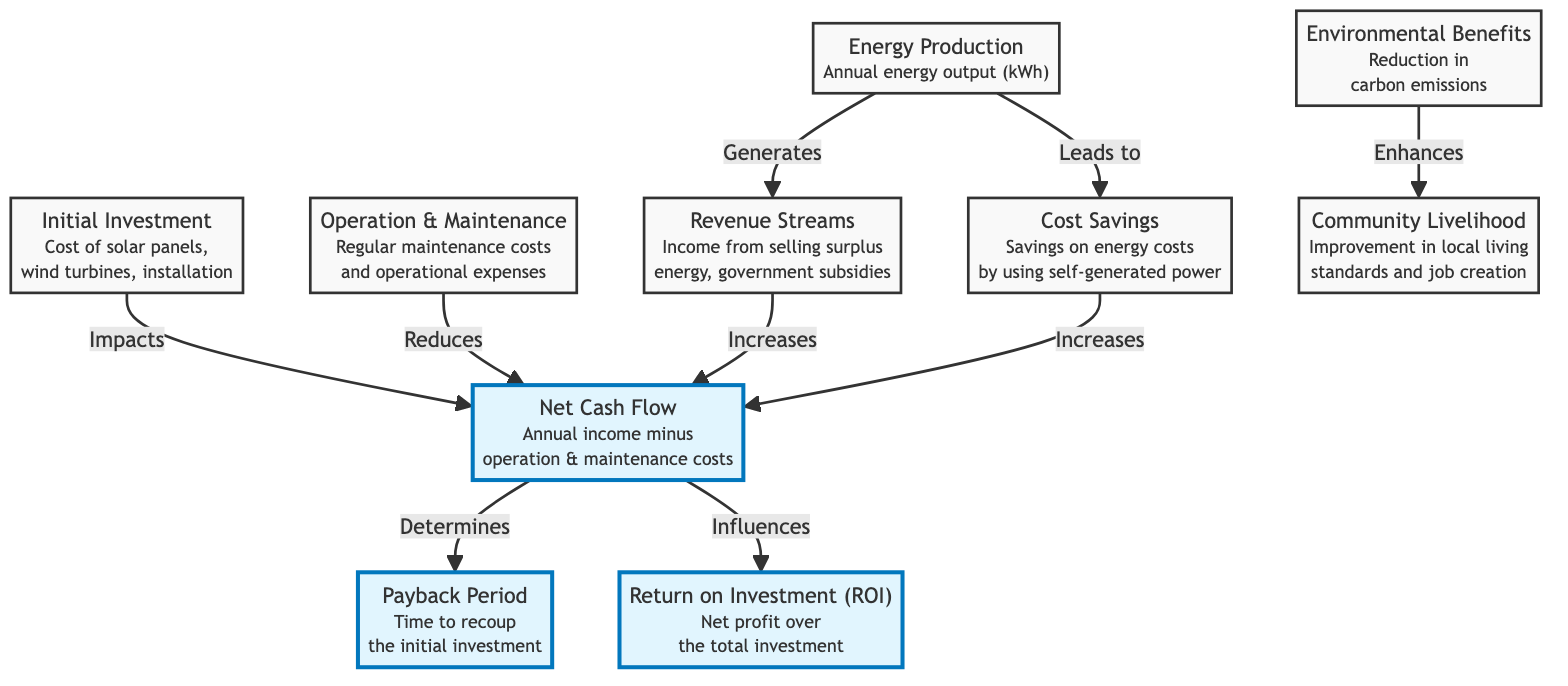What are the components of the initial investment? The initial investment consists of solar panels, wind turbines, and installation costs, as indicated in the diagram.
Answer: Solar panels, wind turbines, installation How does energy production affect revenue streams? Energy production generates revenue streams, meaning that the more energy produced, the more income can arise from selling surplus energy and receiving government subsidies.
Answer: Generates What does the net cash flow influence? The net cash flow influences both the payback period and the return on investment (ROI), as shown by the arrows from net cash flow to these two nodes in the diagram.
Answer: Payback period, ROI What reduces net cash flow? The operation and maintenance costs reduce net cash flow, as depicted in the diagram by the arrow pointing from operation & maintenance to net cash flow.
Answer: Operation & Maintenance Which aspect enhances community livelihood? Environmental benefits enhance community livelihood, indicating that improvements in local living standards and job creation are influenced by the reduction in carbon emissions.
Answer: Environmental benefits How is the payback period determined? The payback period is determined by net cash flow, meaning the period it takes to recover the initial investment relies on the annual income minus the operation and maintenance costs.
Answer: Net cash flow What leads to cost savings? Energy production leads to cost savings by allowing the community to use self-generated power, therefore saving on energy costs.
Answer: Energy production What are the two financial metrics associated with the project? The two financial metrics associated with the project are payback period and return on investment (ROI), both of which are highlighted in the diagram as important outputs.
Answer: Payback period, ROI 